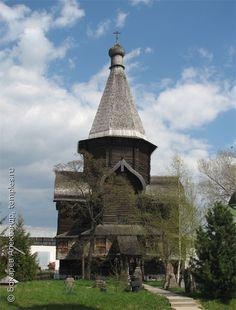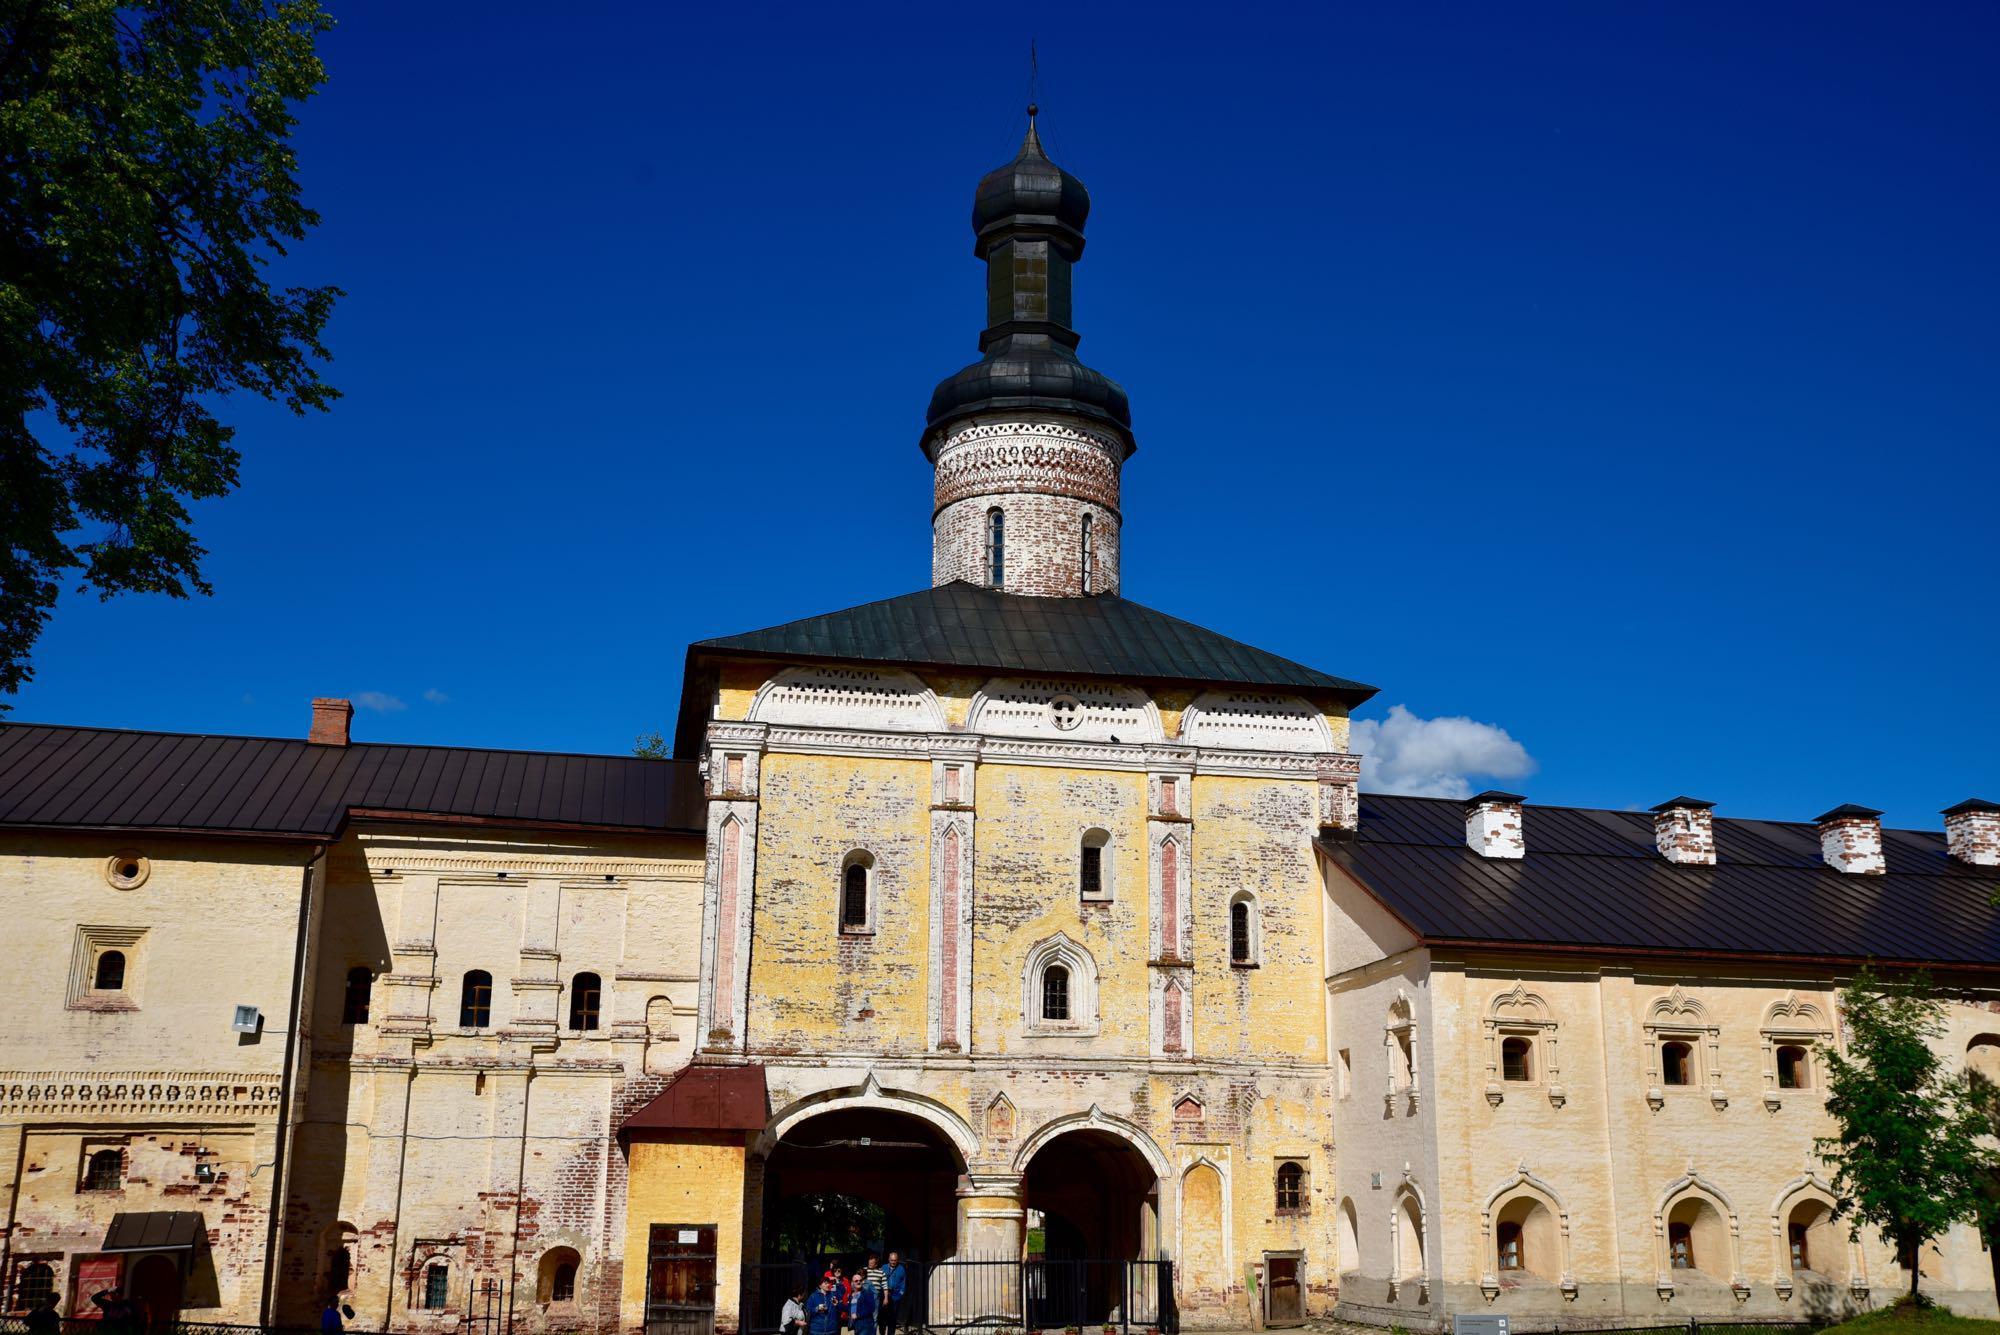The first image is the image on the left, the second image is the image on the right. Given the left and right images, does the statement "An image shows a building with a tall black-topped tower on top of a black peaked roof, in front of a vivid blue with only a tiny cloud patch visible." hold true? Answer yes or no. Yes. The first image is the image on the left, the second image is the image on the right. Evaluate the accuracy of this statement regarding the images: "There are two steeples in the image on the right.". Is it true? Answer yes or no. No. 